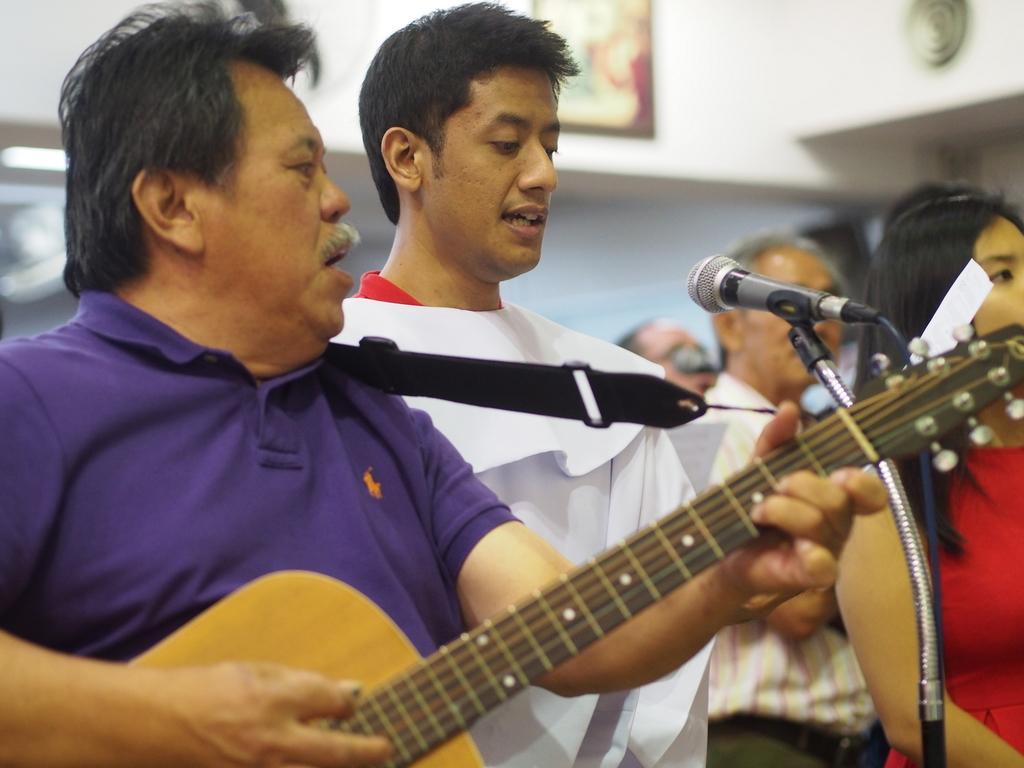How would you summarize this image in a sentence or two? In this image I can see a man wearing violet colored T-Shirt and playing guitar. Beside him I can see another man singing a song wearing a white dress. At the right corner of the image I can see a woman standing,she is wearing red color dress. At background I can see a photo frame which is attached to the wall. I can see few people standing. 